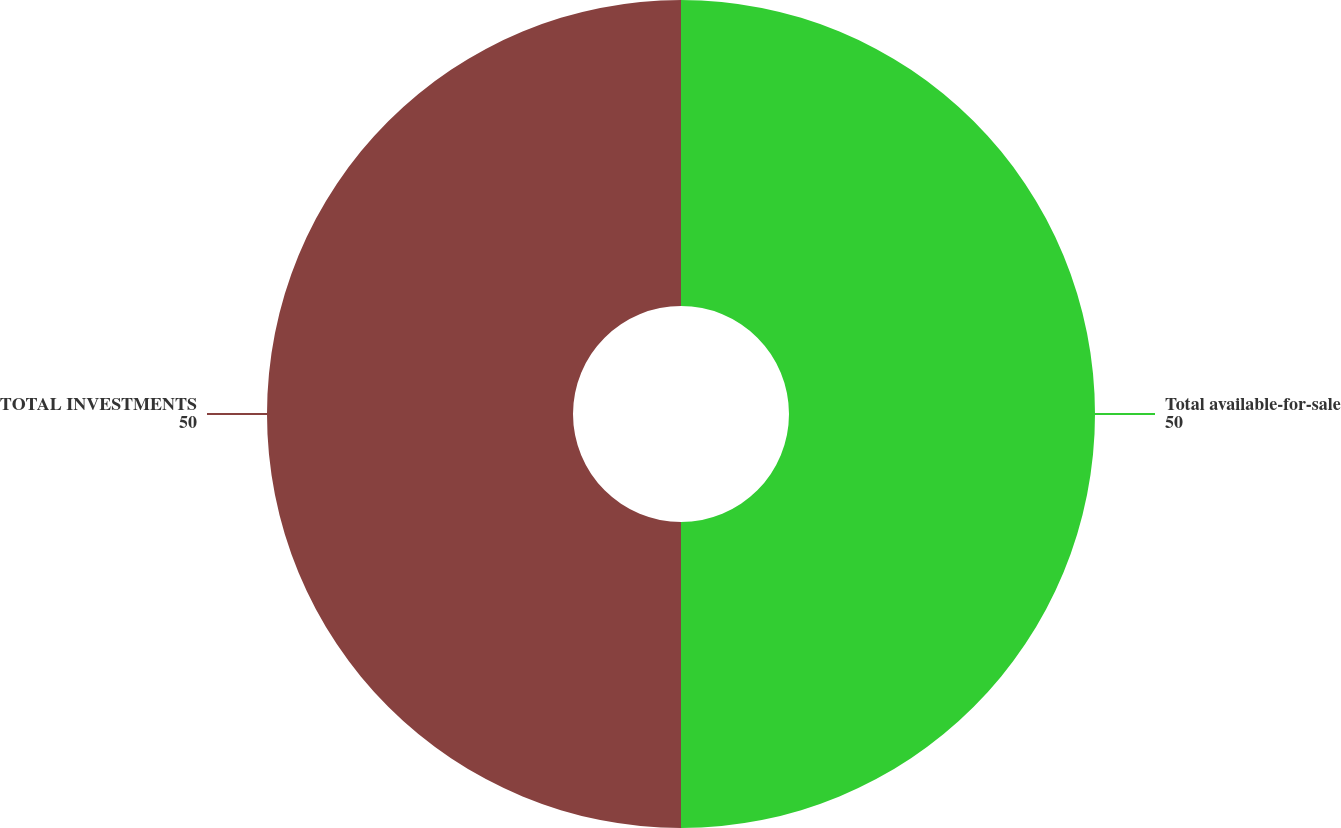Convert chart. <chart><loc_0><loc_0><loc_500><loc_500><pie_chart><fcel>Total available-for-sale<fcel>TOTAL INVESTMENTS<nl><fcel>50.0%<fcel>50.0%<nl></chart> 